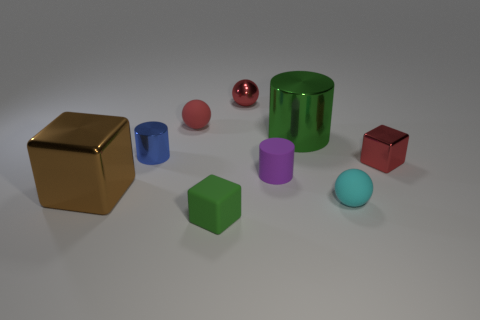Add 1 green rubber objects. How many objects exist? 10 Subtract all balls. How many objects are left? 6 Subtract all tiny cyan matte cylinders. Subtract all green metal things. How many objects are left? 8 Add 6 tiny rubber objects. How many tiny rubber objects are left? 10 Add 8 tiny green things. How many tiny green things exist? 9 Subtract 0 red cylinders. How many objects are left? 9 